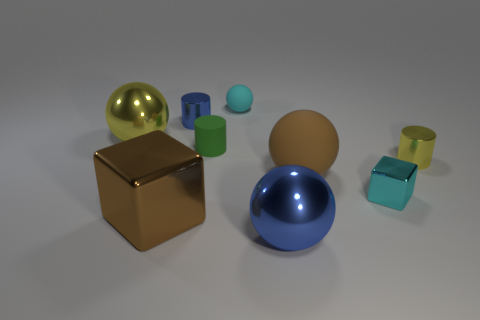Subtract all cyan balls. How many balls are left? 3 Add 1 red balls. How many objects exist? 10 Subtract all cyan spheres. How many spheres are left? 3 Subtract 2 balls. How many balls are left? 2 Subtract all blocks. How many objects are left? 7 Subtract all gray cylinders. Subtract all yellow cubes. How many cylinders are left? 3 Subtract 1 blue cylinders. How many objects are left? 8 Subtract all large green metal cylinders. Subtract all tiny cyan matte balls. How many objects are left? 8 Add 3 large brown blocks. How many large brown blocks are left? 4 Add 6 brown metallic blocks. How many brown metallic blocks exist? 7 